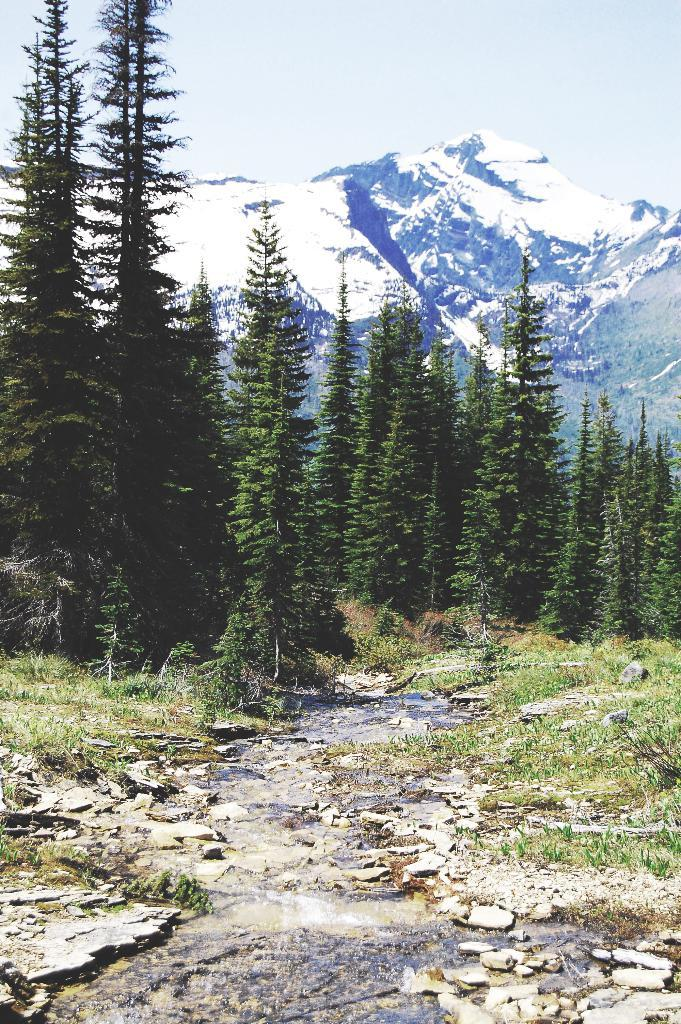What type of vegetation can be seen in the image? There are trees, grass, and plants in the image. What type of natural landforms are visible in the image? There are mountains in the image. What part of the natural environment is visible in the image? The sky, ground, and grass are visible in the image. What other natural elements can be seen in the image? There are rocks in the image. What type of corn can be seen growing in the image? There is no corn present in the image. What type of feast is being prepared in the image? There is no feast or preparation for a feast visible in the image. 